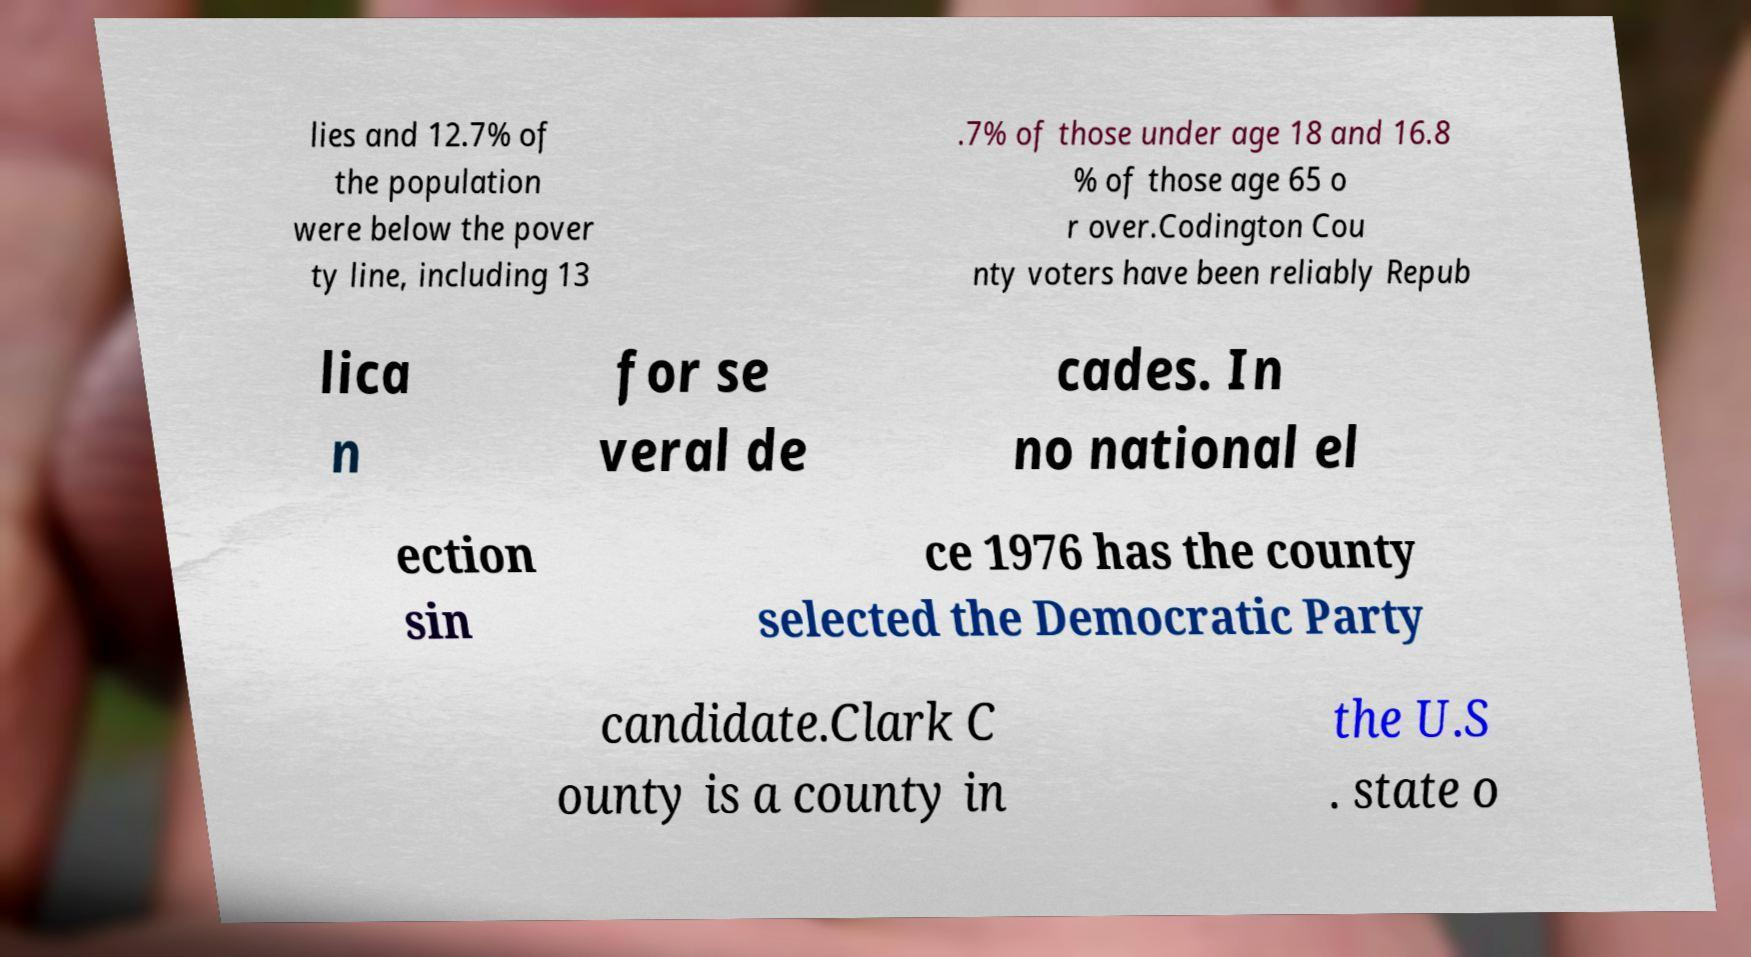Can you read and provide the text displayed in the image?This photo seems to have some interesting text. Can you extract and type it out for me? lies and 12.7% of the population were below the pover ty line, including 13 .7% of those under age 18 and 16.8 % of those age 65 o r over.Codington Cou nty voters have been reliably Repub lica n for se veral de cades. In no national el ection sin ce 1976 has the county selected the Democratic Party candidate.Clark C ounty is a county in the U.S . state o 